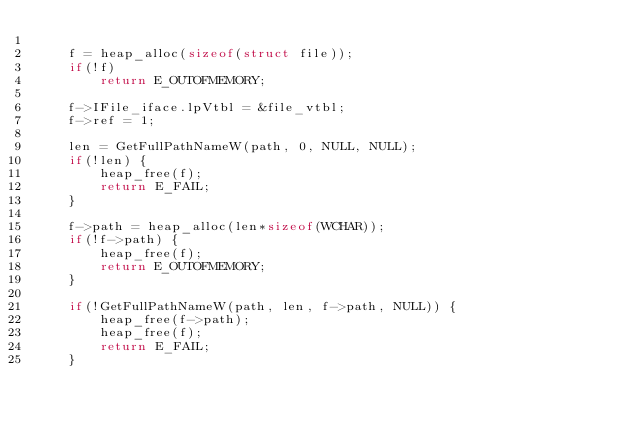<code> <loc_0><loc_0><loc_500><loc_500><_C_>
    f = heap_alloc(sizeof(struct file));
    if(!f)
        return E_OUTOFMEMORY;

    f->IFile_iface.lpVtbl = &file_vtbl;
    f->ref = 1;

    len = GetFullPathNameW(path, 0, NULL, NULL);
    if(!len) {
        heap_free(f);
        return E_FAIL;
    }

    f->path = heap_alloc(len*sizeof(WCHAR));
    if(!f->path) {
        heap_free(f);
        return E_OUTOFMEMORY;
    }

    if(!GetFullPathNameW(path, len, f->path, NULL)) {
        heap_free(f->path);
        heap_free(f);
        return E_FAIL;
    }
</code> 